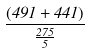<formula> <loc_0><loc_0><loc_500><loc_500>\frac { ( 4 9 1 + 4 4 1 ) } { \frac { 2 7 5 } { 5 } }</formula> 